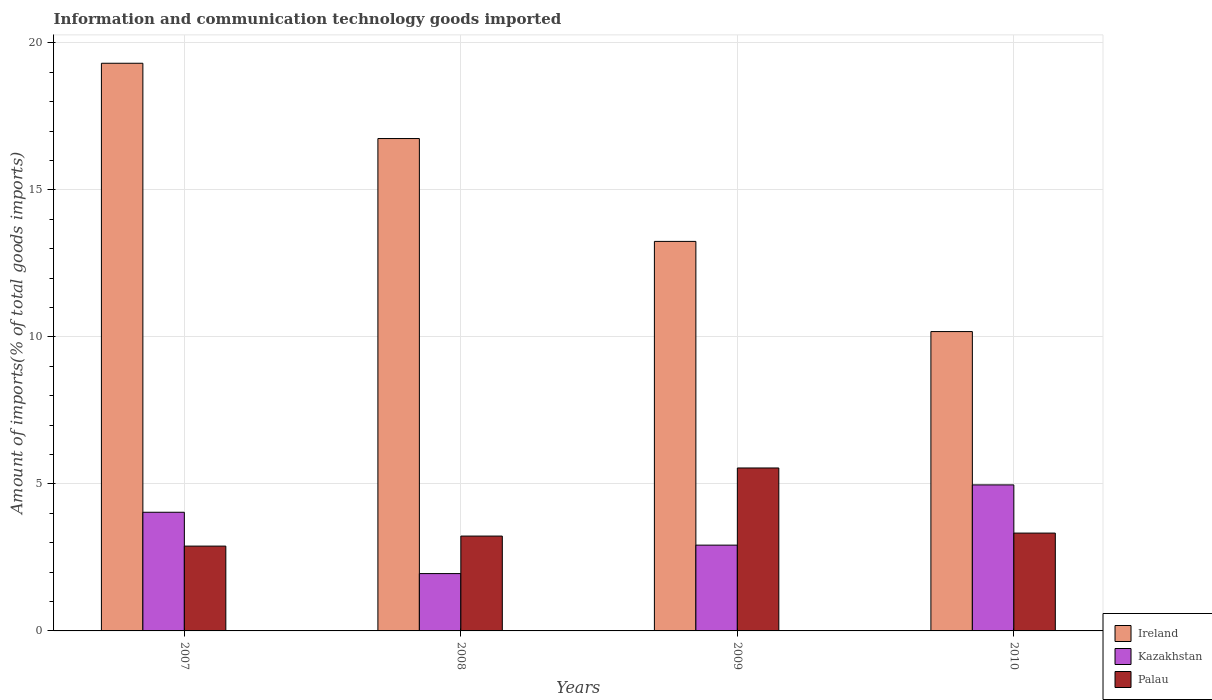Are the number of bars on each tick of the X-axis equal?
Your answer should be compact. Yes. What is the label of the 4th group of bars from the left?
Give a very brief answer. 2010. What is the amount of goods imported in Palau in 2010?
Give a very brief answer. 3.33. Across all years, what is the maximum amount of goods imported in Ireland?
Ensure brevity in your answer.  19.31. Across all years, what is the minimum amount of goods imported in Palau?
Ensure brevity in your answer.  2.89. In which year was the amount of goods imported in Ireland maximum?
Your response must be concise. 2007. In which year was the amount of goods imported in Palau minimum?
Your answer should be compact. 2007. What is the total amount of goods imported in Kazakhstan in the graph?
Your answer should be very brief. 13.87. What is the difference between the amount of goods imported in Palau in 2008 and that in 2010?
Ensure brevity in your answer.  -0.1. What is the difference between the amount of goods imported in Ireland in 2008 and the amount of goods imported in Kazakhstan in 2009?
Your answer should be compact. 13.83. What is the average amount of goods imported in Ireland per year?
Your answer should be very brief. 14.87. In the year 2008, what is the difference between the amount of goods imported in Palau and amount of goods imported in Ireland?
Offer a very short reply. -13.52. In how many years, is the amount of goods imported in Kazakhstan greater than 6 %?
Your answer should be very brief. 0. What is the ratio of the amount of goods imported in Kazakhstan in 2008 to that in 2009?
Give a very brief answer. 0.67. Is the amount of goods imported in Palau in 2007 less than that in 2010?
Give a very brief answer. Yes. Is the difference between the amount of goods imported in Palau in 2009 and 2010 greater than the difference between the amount of goods imported in Ireland in 2009 and 2010?
Ensure brevity in your answer.  No. What is the difference between the highest and the second highest amount of goods imported in Kazakhstan?
Provide a short and direct response. 0.93. What is the difference between the highest and the lowest amount of goods imported in Palau?
Your response must be concise. 2.66. Is the sum of the amount of goods imported in Kazakhstan in 2009 and 2010 greater than the maximum amount of goods imported in Ireland across all years?
Make the answer very short. No. What does the 3rd bar from the left in 2007 represents?
Your answer should be very brief. Palau. What does the 2nd bar from the right in 2009 represents?
Your answer should be very brief. Kazakhstan. Is it the case that in every year, the sum of the amount of goods imported in Ireland and amount of goods imported in Kazakhstan is greater than the amount of goods imported in Palau?
Offer a terse response. Yes. How many years are there in the graph?
Your response must be concise. 4. How are the legend labels stacked?
Keep it short and to the point. Vertical. What is the title of the graph?
Give a very brief answer. Information and communication technology goods imported. Does "Senegal" appear as one of the legend labels in the graph?
Your answer should be very brief. No. What is the label or title of the X-axis?
Your answer should be compact. Years. What is the label or title of the Y-axis?
Ensure brevity in your answer.  Amount of imports(% of total goods imports). What is the Amount of imports(% of total goods imports) of Ireland in 2007?
Give a very brief answer. 19.31. What is the Amount of imports(% of total goods imports) in Kazakhstan in 2007?
Provide a succinct answer. 4.04. What is the Amount of imports(% of total goods imports) in Palau in 2007?
Offer a very short reply. 2.89. What is the Amount of imports(% of total goods imports) of Ireland in 2008?
Offer a terse response. 16.75. What is the Amount of imports(% of total goods imports) in Kazakhstan in 2008?
Provide a short and direct response. 1.95. What is the Amount of imports(% of total goods imports) of Palau in 2008?
Your answer should be very brief. 3.23. What is the Amount of imports(% of total goods imports) in Ireland in 2009?
Provide a succinct answer. 13.25. What is the Amount of imports(% of total goods imports) in Kazakhstan in 2009?
Keep it short and to the point. 2.92. What is the Amount of imports(% of total goods imports) in Palau in 2009?
Offer a very short reply. 5.54. What is the Amount of imports(% of total goods imports) of Ireland in 2010?
Make the answer very short. 10.18. What is the Amount of imports(% of total goods imports) in Kazakhstan in 2010?
Give a very brief answer. 4.97. What is the Amount of imports(% of total goods imports) of Palau in 2010?
Your response must be concise. 3.33. Across all years, what is the maximum Amount of imports(% of total goods imports) in Ireland?
Provide a short and direct response. 19.31. Across all years, what is the maximum Amount of imports(% of total goods imports) of Kazakhstan?
Your answer should be compact. 4.97. Across all years, what is the maximum Amount of imports(% of total goods imports) of Palau?
Offer a terse response. 5.54. Across all years, what is the minimum Amount of imports(% of total goods imports) in Ireland?
Make the answer very short. 10.18. Across all years, what is the minimum Amount of imports(% of total goods imports) in Kazakhstan?
Provide a short and direct response. 1.95. Across all years, what is the minimum Amount of imports(% of total goods imports) of Palau?
Provide a short and direct response. 2.89. What is the total Amount of imports(% of total goods imports) of Ireland in the graph?
Provide a succinct answer. 59.49. What is the total Amount of imports(% of total goods imports) in Kazakhstan in the graph?
Offer a terse response. 13.87. What is the total Amount of imports(% of total goods imports) of Palau in the graph?
Make the answer very short. 14.98. What is the difference between the Amount of imports(% of total goods imports) in Ireland in 2007 and that in 2008?
Keep it short and to the point. 2.56. What is the difference between the Amount of imports(% of total goods imports) of Kazakhstan in 2007 and that in 2008?
Offer a terse response. 2.09. What is the difference between the Amount of imports(% of total goods imports) in Palau in 2007 and that in 2008?
Your answer should be very brief. -0.34. What is the difference between the Amount of imports(% of total goods imports) in Ireland in 2007 and that in 2009?
Your response must be concise. 6.06. What is the difference between the Amount of imports(% of total goods imports) in Kazakhstan in 2007 and that in 2009?
Give a very brief answer. 1.12. What is the difference between the Amount of imports(% of total goods imports) in Palau in 2007 and that in 2009?
Keep it short and to the point. -2.66. What is the difference between the Amount of imports(% of total goods imports) of Ireland in 2007 and that in 2010?
Your answer should be compact. 9.13. What is the difference between the Amount of imports(% of total goods imports) of Kazakhstan in 2007 and that in 2010?
Your answer should be compact. -0.93. What is the difference between the Amount of imports(% of total goods imports) of Palau in 2007 and that in 2010?
Your answer should be very brief. -0.44. What is the difference between the Amount of imports(% of total goods imports) in Ireland in 2008 and that in 2009?
Offer a very short reply. 3.5. What is the difference between the Amount of imports(% of total goods imports) of Kazakhstan in 2008 and that in 2009?
Offer a terse response. -0.97. What is the difference between the Amount of imports(% of total goods imports) in Palau in 2008 and that in 2009?
Provide a succinct answer. -2.32. What is the difference between the Amount of imports(% of total goods imports) of Ireland in 2008 and that in 2010?
Your answer should be compact. 6.57. What is the difference between the Amount of imports(% of total goods imports) of Kazakhstan in 2008 and that in 2010?
Offer a very short reply. -3.02. What is the difference between the Amount of imports(% of total goods imports) of Palau in 2008 and that in 2010?
Offer a terse response. -0.1. What is the difference between the Amount of imports(% of total goods imports) in Ireland in 2009 and that in 2010?
Give a very brief answer. 3.07. What is the difference between the Amount of imports(% of total goods imports) in Kazakhstan in 2009 and that in 2010?
Your answer should be compact. -2.05. What is the difference between the Amount of imports(% of total goods imports) of Palau in 2009 and that in 2010?
Your answer should be very brief. 2.22. What is the difference between the Amount of imports(% of total goods imports) in Ireland in 2007 and the Amount of imports(% of total goods imports) in Kazakhstan in 2008?
Your answer should be very brief. 17.36. What is the difference between the Amount of imports(% of total goods imports) in Ireland in 2007 and the Amount of imports(% of total goods imports) in Palau in 2008?
Ensure brevity in your answer.  16.08. What is the difference between the Amount of imports(% of total goods imports) in Kazakhstan in 2007 and the Amount of imports(% of total goods imports) in Palau in 2008?
Make the answer very short. 0.81. What is the difference between the Amount of imports(% of total goods imports) in Ireland in 2007 and the Amount of imports(% of total goods imports) in Kazakhstan in 2009?
Offer a very short reply. 16.39. What is the difference between the Amount of imports(% of total goods imports) in Ireland in 2007 and the Amount of imports(% of total goods imports) in Palau in 2009?
Keep it short and to the point. 13.77. What is the difference between the Amount of imports(% of total goods imports) in Kazakhstan in 2007 and the Amount of imports(% of total goods imports) in Palau in 2009?
Offer a terse response. -1.51. What is the difference between the Amount of imports(% of total goods imports) in Ireland in 2007 and the Amount of imports(% of total goods imports) in Kazakhstan in 2010?
Make the answer very short. 14.34. What is the difference between the Amount of imports(% of total goods imports) in Ireland in 2007 and the Amount of imports(% of total goods imports) in Palau in 2010?
Keep it short and to the point. 15.98. What is the difference between the Amount of imports(% of total goods imports) in Kazakhstan in 2007 and the Amount of imports(% of total goods imports) in Palau in 2010?
Your answer should be very brief. 0.71. What is the difference between the Amount of imports(% of total goods imports) in Ireland in 2008 and the Amount of imports(% of total goods imports) in Kazakhstan in 2009?
Offer a terse response. 13.83. What is the difference between the Amount of imports(% of total goods imports) of Ireland in 2008 and the Amount of imports(% of total goods imports) of Palau in 2009?
Give a very brief answer. 11.21. What is the difference between the Amount of imports(% of total goods imports) in Kazakhstan in 2008 and the Amount of imports(% of total goods imports) in Palau in 2009?
Offer a terse response. -3.59. What is the difference between the Amount of imports(% of total goods imports) in Ireland in 2008 and the Amount of imports(% of total goods imports) in Kazakhstan in 2010?
Offer a terse response. 11.78. What is the difference between the Amount of imports(% of total goods imports) of Ireland in 2008 and the Amount of imports(% of total goods imports) of Palau in 2010?
Ensure brevity in your answer.  13.42. What is the difference between the Amount of imports(% of total goods imports) in Kazakhstan in 2008 and the Amount of imports(% of total goods imports) in Palau in 2010?
Keep it short and to the point. -1.38. What is the difference between the Amount of imports(% of total goods imports) of Ireland in 2009 and the Amount of imports(% of total goods imports) of Kazakhstan in 2010?
Provide a succinct answer. 8.28. What is the difference between the Amount of imports(% of total goods imports) in Ireland in 2009 and the Amount of imports(% of total goods imports) in Palau in 2010?
Offer a very short reply. 9.92. What is the difference between the Amount of imports(% of total goods imports) in Kazakhstan in 2009 and the Amount of imports(% of total goods imports) in Palau in 2010?
Keep it short and to the point. -0.41. What is the average Amount of imports(% of total goods imports) of Ireland per year?
Provide a short and direct response. 14.87. What is the average Amount of imports(% of total goods imports) of Kazakhstan per year?
Ensure brevity in your answer.  3.47. What is the average Amount of imports(% of total goods imports) of Palau per year?
Keep it short and to the point. 3.75. In the year 2007, what is the difference between the Amount of imports(% of total goods imports) of Ireland and Amount of imports(% of total goods imports) of Kazakhstan?
Your answer should be compact. 15.27. In the year 2007, what is the difference between the Amount of imports(% of total goods imports) in Ireland and Amount of imports(% of total goods imports) in Palau?
Your answer should be compact. 16.43. In the year 2007, what is the difference between the Amount of imports(% of total goods imports) of Kazakhstan and Amount of imports(% of total goods imports) of Palau?
Keep it short and to the point. 1.15. In the year 2008, what is the difference between the Amount of imports(% of total goods imports) of Ireland and Amount of imports(% of total goods imports) of Kazakhstan?
Ensure brevity in your answer.  14.8. In the year 2008, what is the difference between the Amount of imports(% of total goods imports) in Ireland and Amount of imports(% of total goods imports) in Palau?
Offer a terse response. 13.52. In the year 2008, what is the difference between the Amount of imports(% of total goods imports) of Kazakhstan and Amount of imports(% of total goods imports) of Palau?
Your answer should be compact. -1.28. In the year 2009, what is the difference between the Amount of imports(% of total goods imports) of Ireland and Amount of imports(% of total goods imports) of Kazakhstan?
Provide a succinct answer. 10.33. In the year 2009, what is the difference between the Amount of imports(% of total goods imports) in Ireland and Amount of imports(% of total goods imports) in Palau?
Your answer should be compact. 7.71. In the year 2009, what is the difference between the Amount of imports(% of total goods imports) in Kazakhstan and Amount of imports(% of total goods imports) in Palau?
Provide a short and direct response. -2.62. In the year 2010, what is the difference between the Amount of imports(% of total goods imports) of Ireland and Amount of imports(% of total goods imports) of Kazakhstan?
Offer a very short reply. 5.22. In the year 2010, what is the difference between the Amount of imports(% of total goods imports) of Ireland and Amount of imports(% of total goods imports) of Palau?
Ensure brevity in your answer.  6.86. In the year 2010, what is the difference between the Amount of imports(% of total goods imports) in Kazakhstan and Amount of imports(% of total goods imports) in Palau?
Offer a very short reply. 1.64. What is the ratio of the Amount of imports(% of total goods imports) in Ireland in 2007 to that in 2008?
Your answer should be compact. 1.15. What is the ratio of the Amount of imports(% of total goods imports) of Kazakhstan in 2007 to that in 2008?
Your answer should be very brief. 2.07. What is the ratio of the Amount of imports(% of total goods imports) in Palau in 2007 to that in 2008?
Keep it short and to the point. 0.89. What is the ratio of the Amount of imports(% of total goods imports) in Ireland in 2007 to that in 2009?
Your response must be concise. 1.46. What is the ratio of the Amount of imports(% of total goods imports) in Kazakhstan in 2007 to that in 2009?
Provide a short and direct response. 1.38. What is the ratio of the Amount of imports(% of total goods imports) in Palau in 2007 to that in 2009?
Give a very brief answer. 0.52. What is the ratio of the Amount of imports(% of total goods imports) of Ireland in 2007 to that in 2010?
Provide a short and direct response. 1.9. What is the ratio of the Amount of imports(% of total goods imports) of Kazakhstan in 2007 to that in 2010?
Offer a terse response. 0.81. What is the ratio of the Amount of imports(% of total goods imports) in Palau in 2007 to that in 2010?
Keep it short and to the point. 0.87. What is the ratio of the Amount of imports(% of total goods imports) in Ireland in 2008 to that in 2009?
Your answer should be very brief. 1.26. What is the ratio of the Amount of imports(% of total goods imports) of Kazakhstan in 2008 to that in 2009?
Offer a terse response. 0.67. What is the ratio of the Amount of imports(% of total goods imports) of Palau in 2008 to that in 2009?
Provide a short and direct response. 0.58. What is the ratio of the Amount of imports(% of total goods imports) in Ireland in 2008 to that in 2010?
Make the answer very short. 1.64. What is the ratio of the Amount of imports(% of total goods imports) in Kazakhstan in 2008 to that in 2010?
Provide a short and direct response. 0.39. What is the ratio of the Amount of imports(% of total goods imports) in Palau in 2008 to that in 2010?
Your answer should be compact. 0.97. What is the ratio of the Amount of imports(% of total goods imports) in Ireland in 2009 to that in 2010?
Give a very brief answer. 1.3. What is the ratio of the Amount of imports(% of total goods imports) of Kazakhstan in 2009 to that in 2010?
Keep it short and to the point. 0.59. What is the ratio of the Amount of imports(% of total goods imports) of Palau in 2009 to that in 2010?
Provide a short and direct response. 1.67. What is the difference between the highest and the second highest Amount of imports(% of total goods imports) of Ireland?
Your response must be concise. 2.56. What is the difference between the highest and the second highest Amount of imports(% of total goods imports) in Kazakhstan?
Offer a very short reply. 0.93. What is the difference between the highest and the second highest Amount of imports(% of total goods imports) in Palau?
Your response must be concise. 2.22. What is the difference between the highest and the lowest Amount of imports(% of total goods imports) of Ireland?
Provide a short and direct response. 9.13. What is the difference between the highest and the lowest Amount of imports(% of total goods imports) in Kazakhstan?
Offer a very short reply. 3.02. What is the difference between the highest and the lowest Amount of imports(% of total goods imports) of Palau?
Offer a very short reply. 2.66. 